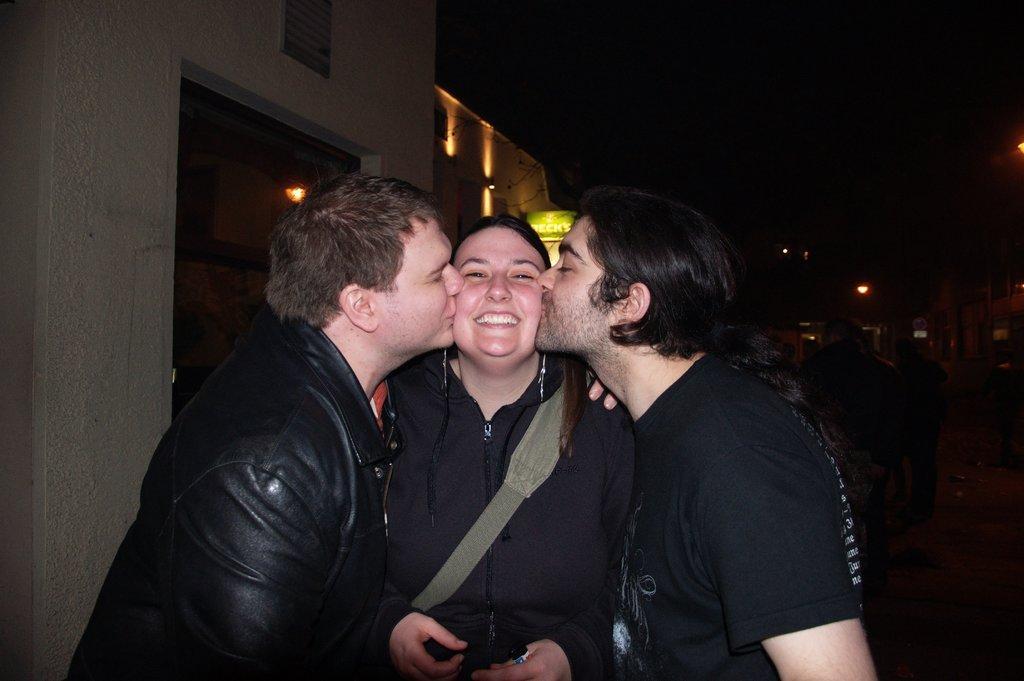Please provide a concise description of this image. There are three people standing. Two men and one women. These two men are kissing the women. Here I can see frame attached to the wall. These are the lightnings on the building. And background looks dark. Here I can see another person standing. 